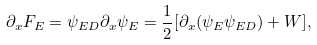Convert formula to latex. <formula><loc_0><loc_0><loc_500><loc_500>\partial _ { x } F _ { E } = \psi _ { E D } \partial _ { x } \psi _ { E } = \frac { 1 } { 2 } [ \partial _ { x } ( \psi _ { E } \psi _ { E D } ) + W ] ,</formula> 